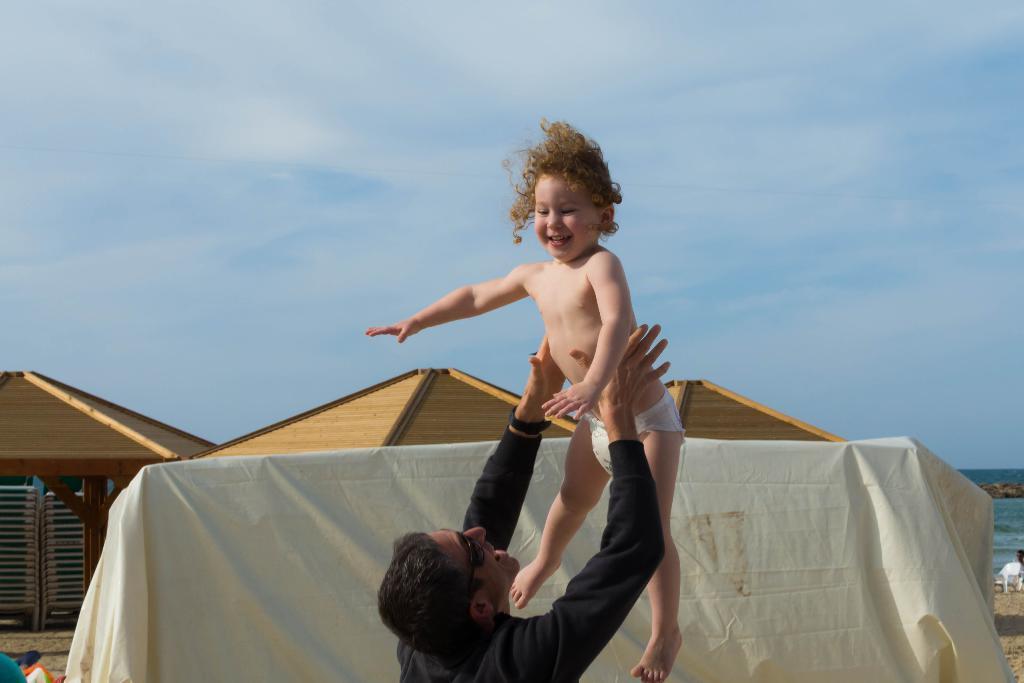How would you summarize this image in a sentence or two? In the picture I can see a kid in the air and there is a person wearing black dress is holding her and there are some other objects in the background. 